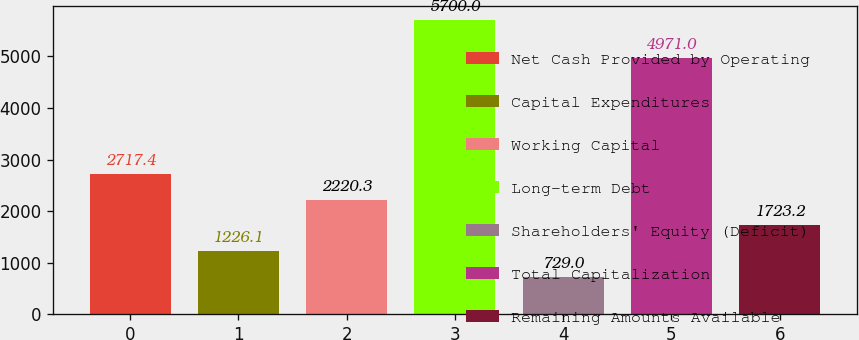<chart> <loc_0><loc_0><loc_500><loc_500><bar_chart><fcel>Net Cash Provided by Operating<fcel>Capital Expenditures<fcel>Working Capital<fcel>Long-term Debt<fcel>Shareholders' Equity (Deficit)<fcel>Total Capitalization<fcel>Remaining Amounts Available<nl><fcel>2717.4<fcel>1226.1<fcel>2220.3<fcel>5700<fcel>729<fcel>4971<fcel>1723.2<nl></chart> 